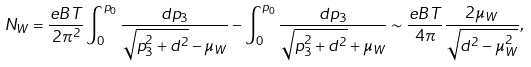Convert formula to latex. <formula><loc_0><loc_0><loc_500><loc_500>N _ { W } = \frac { e B T } { 2 \pi ^ { 2 } } \int _ { 0 } ^ { p _ { 0 } } \frac { d p _ { 3 } } { \sqrt { p _ { 3 } ^ { 2 } + d ^ { 2 } } - \mu _ { W } } - \int _ { 0 } ^ { p _ { 0 } } \frac { d p _ { 3 } } { \sqrt { p _ { 3 } ^ { 2 } + d ^ { 2 } } + \mu _ { W } } \sim \frac { e B T } { 4 \pi } \frac { 2 \mu _ { W } } { \sqrt { d ^ { 2 } - \mu _ { W } ^ { 2 } } } ,</formula> 